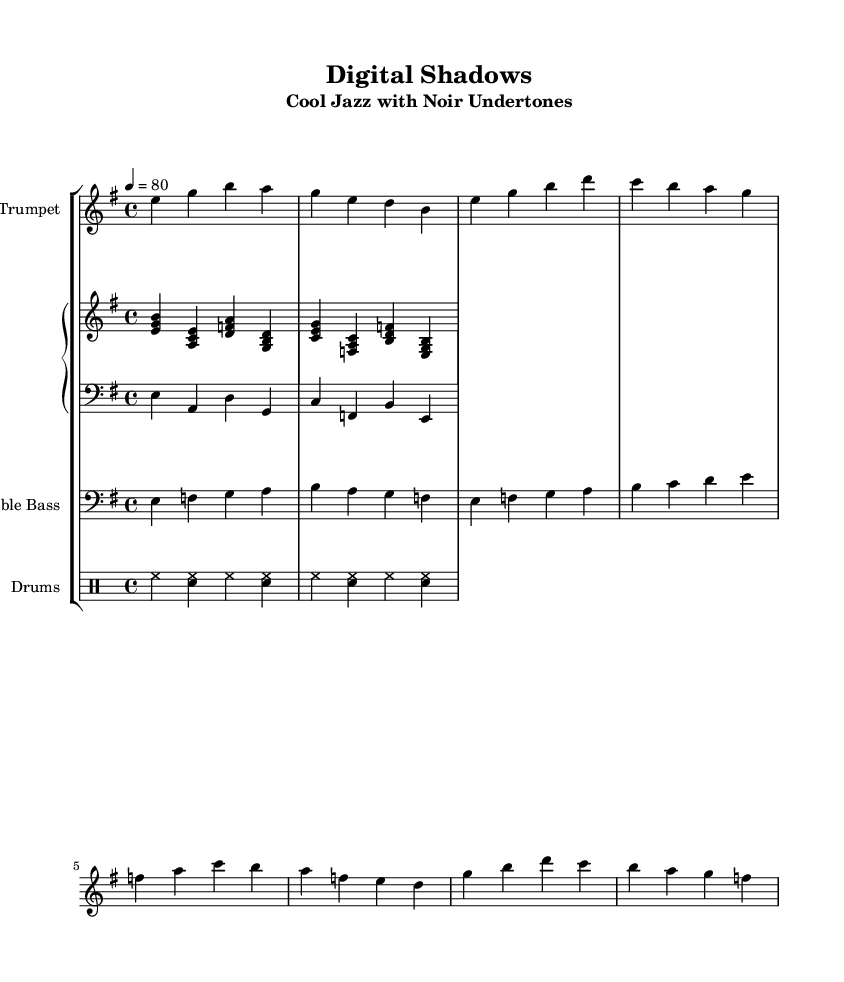What is the key signature of this music? The key signature is E minor, which contains one sharp (F#). This can be determined from the key signature information indicated at the beginning of the score.
Answer: E minor What is the time signature of the piece? The time signature is 4/4, as indicated in the sequence of numbers at the beginning of the score, displaying how many beats are in a measure and what note value is counted as a beat.
Answer: 4/4 What is the tempo marked in this music? The tempo is marked as "4 = 80", where the number 4 represents the quarter note and 80 indicates the beats per minute. This is visible in the tempo markings at the top of the score.
Answer: 80 What instrument plays the main melody? The main melody is played by the muted trumpet, which can be identified as it is the first staff mentioned and contains the melodic line above the piano parts.
Answer: Muted Trumpet How many measures are in the trumpet part? The trumpet part contains 8 measures, as counted by observing the bar lines dividing the music into distinct segments, each containing a specific number of beats.
Answer: 8 Which chord is played in the first measure of the piano right hand? The chord played in the first measure of the piano right hand is E minor, represented by the notes E, G, and B played together. This can be found by analyzing the notes within the first measure of the piano right-hand staff.
Answer: E minor How does the rhythm of the drums complement the jazz style of this piece? The rhythm of the drums emphasizes the high-hat on beats and creates a steady pulse with snare drum accents, typical of cool jazz, which aims to produce a laid-back and relaxed feel. This can be deduced by observing the specific notation for the drums in the drumming staff, illustrating their role in maintaining the rhythm.
Answer: Laid-back 